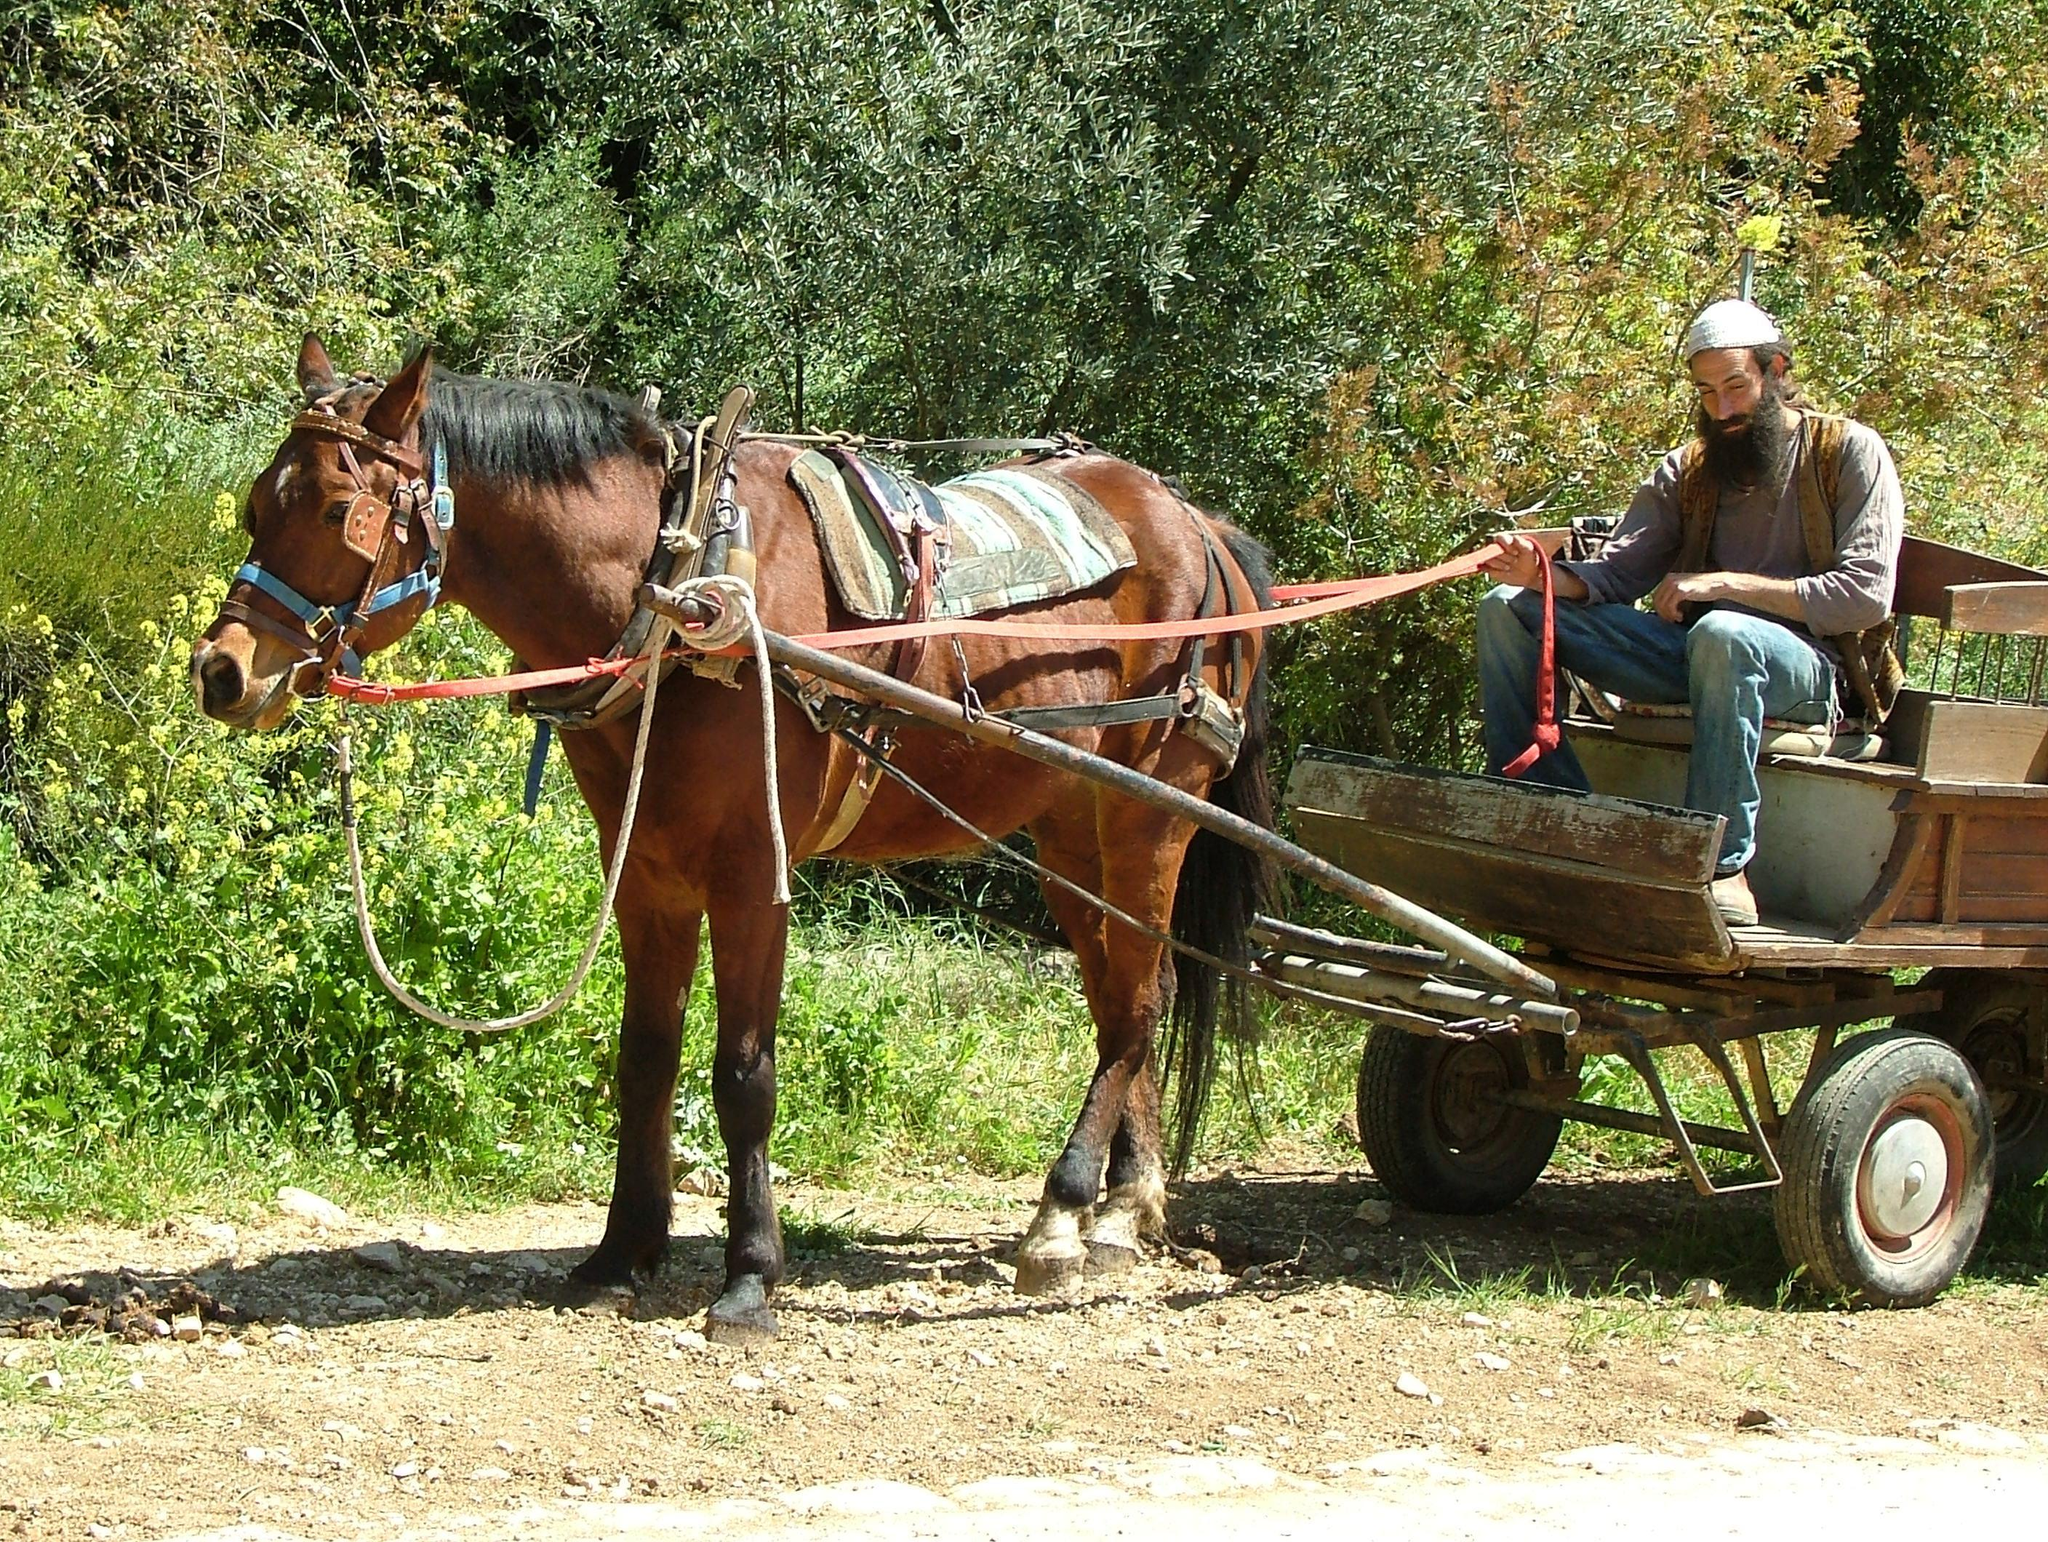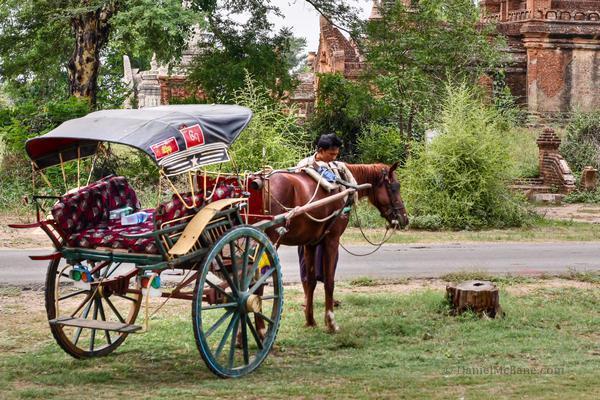The first image is the image on the left, the second image is the image on the right. Given the left and right images, does the statement "Each image shows a wagon hitched to a brown horse." hold true? Answer yes or no. Yes. 